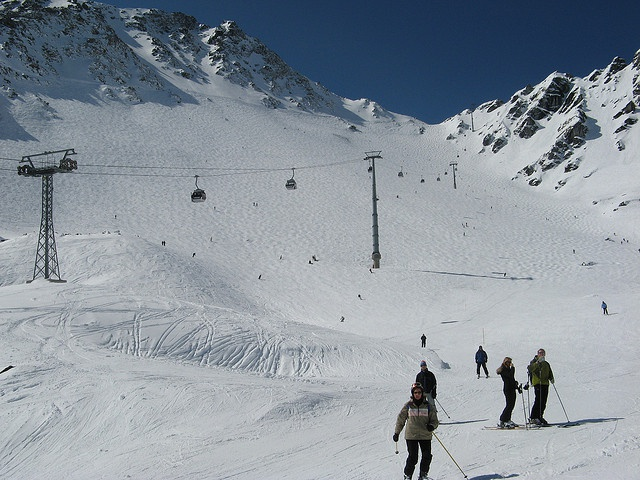Describe the objects in this image and their specific colors. I can see people in black, gray, and darkgray tones, people in black, gray, darkgray, and darkgreen tones, people in black, gray, darkgray, and lightgray tones, people in black, gray, purple, and darkgray tones, and people in black, navy, gray, and darkgray tones in this image. 